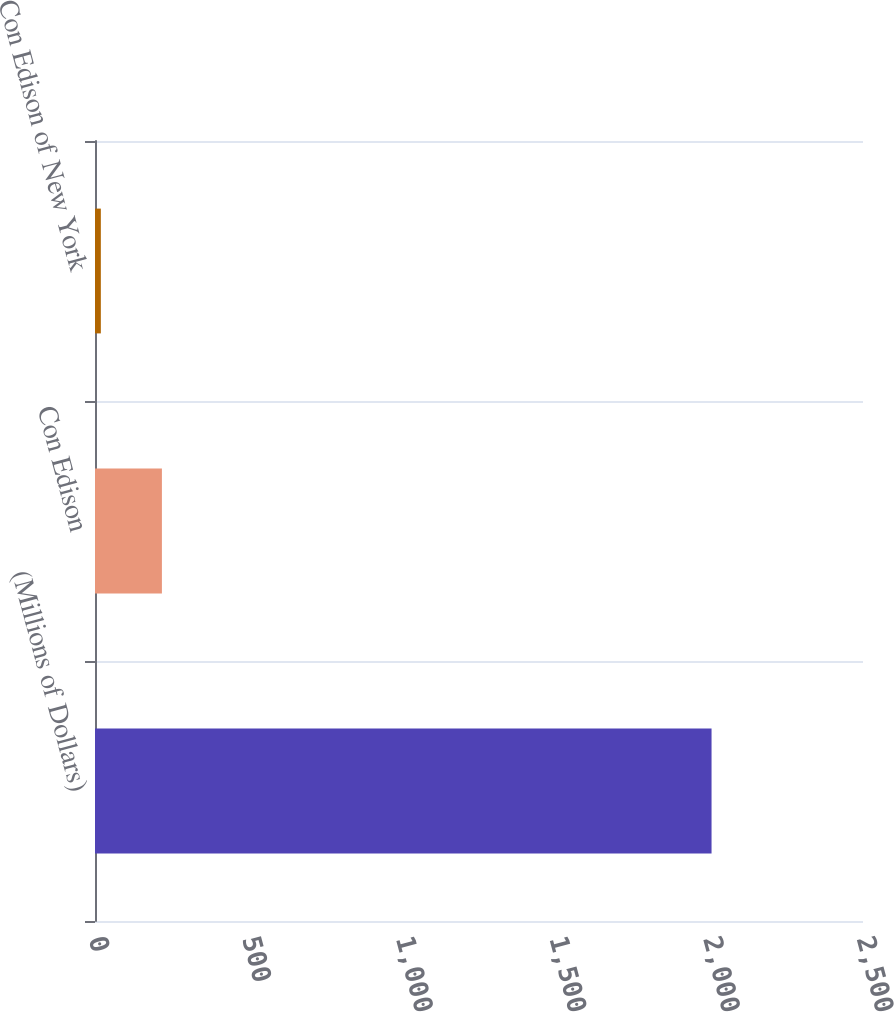<chart> <loc_0><loc_0><loc_500><loc_500><bar_chart><fcel>(Millions of Dollars)<fcel>Con Edison<fcel>Con Edison of New York<nl><fcel>2007<fcel>217.8<fcel>19<nl></chart> 